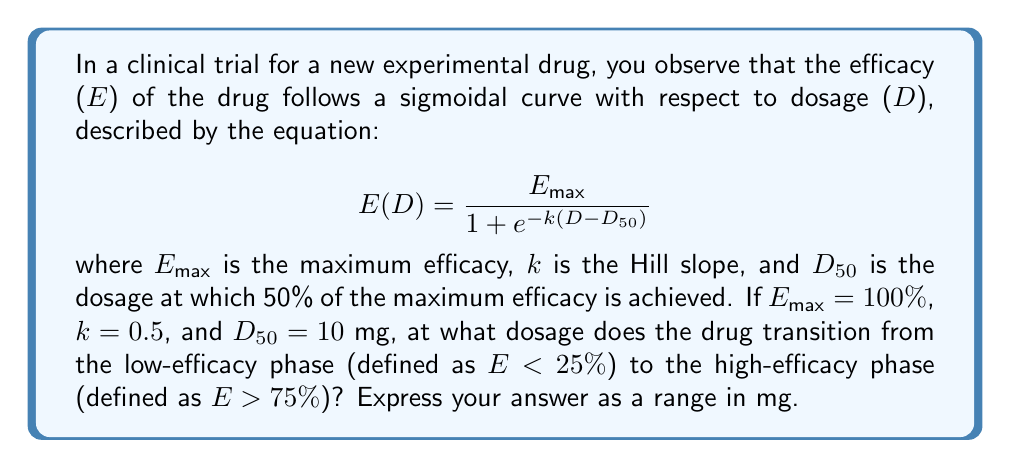Solve this math problem. To solve this problem, we need to find the dosages at which the efficacy is 25% and 75%. These dosages will define the transition range from low-efficacy to high-efficacy phases.

Step 1: Set up the equation for 25% efficacy
$$25 = \frac{100}{1 + e^{-0.5(D-10)}}$$

Step 2: Solve for D at 25% efficacy
$$1 + e^{-0.5(D-10)} = 4$$
$$e^{-0.5(D-10)} = 3$$
$$-0.5(D-10) = \ln(3)$$
$$D-10 = -2\ln(3)$$
$$D = 10 - 2\ln(3) \approx 7.80 \text{ mg}$$

Step 3: Set up the equation for 75% efficacy
$$75 = \frac{100}{1 + e^{-0.5(D-10)}}$$

Step 4: Solve for D at 75% efficacy
$$1 + e^{-0.5(D-10)} = \frac{4}{3}$$
$$e^{-0.5(D-10)} = \frac{1}{3}$$
$$-0.5(D-10) = \ln(\frac{1}{3}) = -\ln(3)$$
$$D-10 = 2\ln(3)$$
$$D = 10 + 2\ln(3) \approx 12.20 \text{ mg}$$

Step 5: Express the transition range
The drug transitions from low-efficacy to high-efficacy phase between 7.80 mg and 12.20 mg.
Answer: [7.80, 12.20] mg 